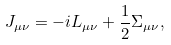Convert formula to latex. <formula><loc_0><loc_0><loc_500><loc_500>J _ { \mu \nu } & = - i L _ { \mu \nu } + \frac { 1 } { 2 } \Sigma _ { \mu \nu } ,</formula> 